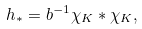<formula> <loc_0><loc_0><loc_500><loc_500>h _ { * } = b ^ { - 1 } \chi _ { K } * \chi _ { K } ,</formula> 